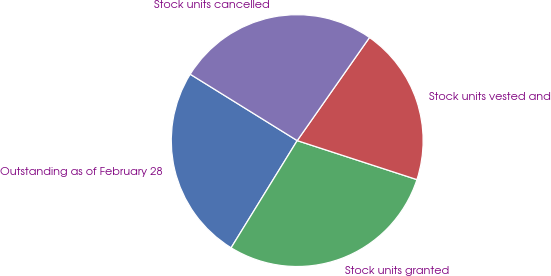<chart> <loc_0><loc_0><loc_500><loc_500><pie_chart><fcel>Outstanding as of February 28<fcel>Stock units granted<fcel>Stock units vested and<fcel>Stock units cancelled<nl><fcel>25.04%<fcel>28.78%<fcel>20.28%<fcel>25.89%<nl></chart> 